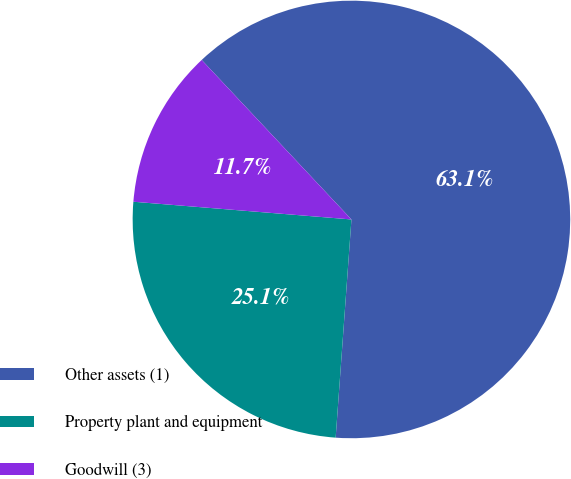Convert chart to OTSL. <chart><loc_0><loc_0><loc_500><loc_500><pie_chart><fcel>Other assets (1)<fcel>Property plant and equipment<fcel>Goodwill (3)<nl><fcel>63.14%<fcel>25.14%<fcel>11.71%<nl></chart> 